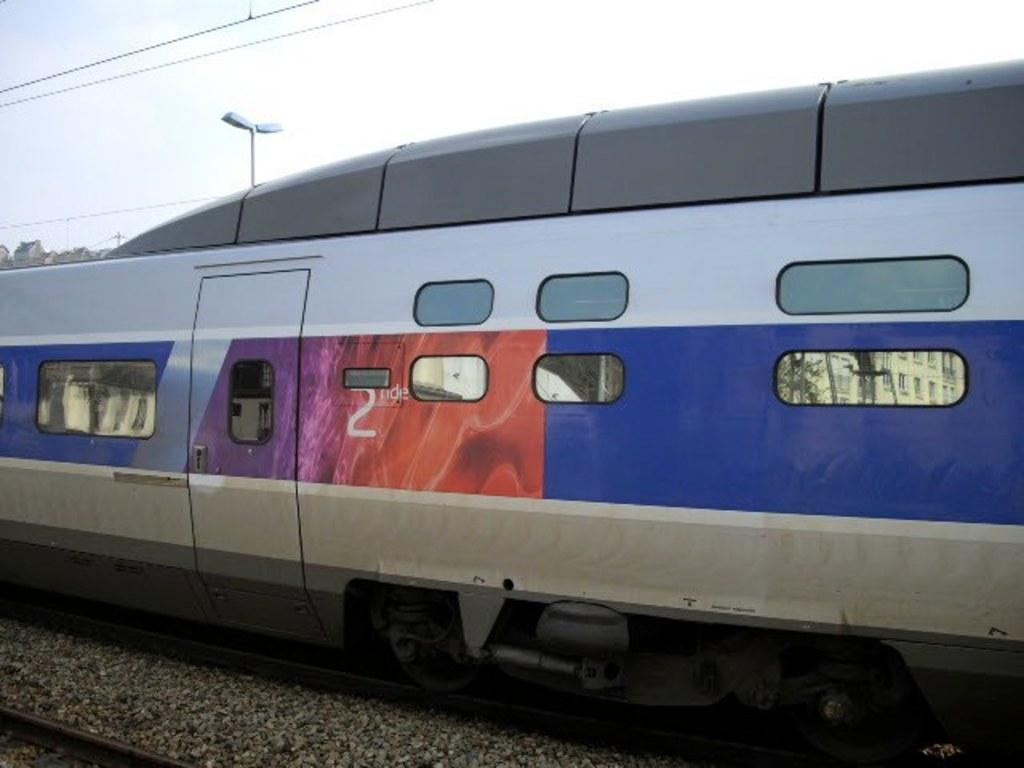What can be seen in the foreground of the picture? In the foreground of the picture, there are stones, a railway track, and a train. What is present in the background of the picture? In the background of the picture, there are cables, a street light, and buildings. Can you describe the railway track in the foreground? The railway track in the foreground is visible alongside the stones and the train. How many elements can be seen in the background of the picture? There are three elements in the background of the picture: cables, a street light, and buildings. Where is the faucet located in the image? There is no faucet present in the image. What type of slope can be seen in the image? There is no slope visible in the image. 